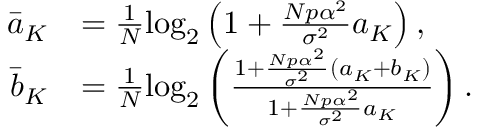Convert formula to latex. <formula><loc_0><loc_0><loc_500><loc_500>\begin{array} { r l } { \bar { a } _ { K } } & { = \frac { 1 } { N } \log _ { 2 } \left ( 1 + \frac { N p \alpha ^ { 2 } } { \sigma ^ { 2 } } a _ { K } \right ) , } \\ { \bar { b } _ { K } } & { = \frac { 1 } { N } \log _ { 2 } \left ( \frac { 1 + \frac { N p \alpha ^ { 2 } } { \sigma ^ { 2 } } \left ( a _ { K } + b _ { K } \right ) } { 1 + \frac { N p \alpha ^ { 2 } } { \sigma ^ { 2 } } a _ { K } } \right ) . } \end{array}</formula> 